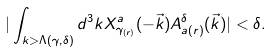Convert formula to latex. <formula><loc_0><loc_0><loc_500><loc_500>| \int _ { k > \Lambda ( \gamma , \delta ) } d ^ { 3 } k X ^ { a } _ { \gamma _ { ( r ) } } ( - { \vec { k } } ) A ^ { \delta } _ { a ( r ) } ( { \vec { k } } ) | < \delta .</formula> 